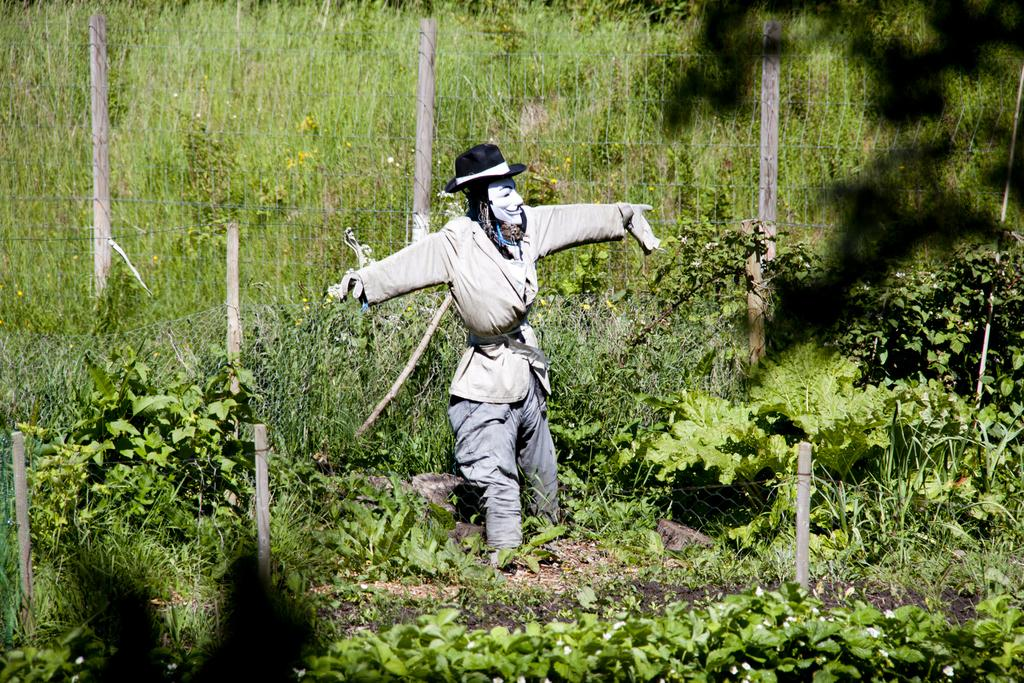What is present on the ground at the bottom of the image? There are plants on the ground at the bottom of the image. What type of object can be seen in the image? There is a toy in the image. What is on the toy's head? There is a hat on the toy's head. What can be seen in the background of the image? There is a fence, poles, and plants in the background of the image. Can you tell me how many times the toy sneezes in the image? There is no indication of the toy sneezing in the image. What type of bubble is present in the image? There is no bubble present in the image. 